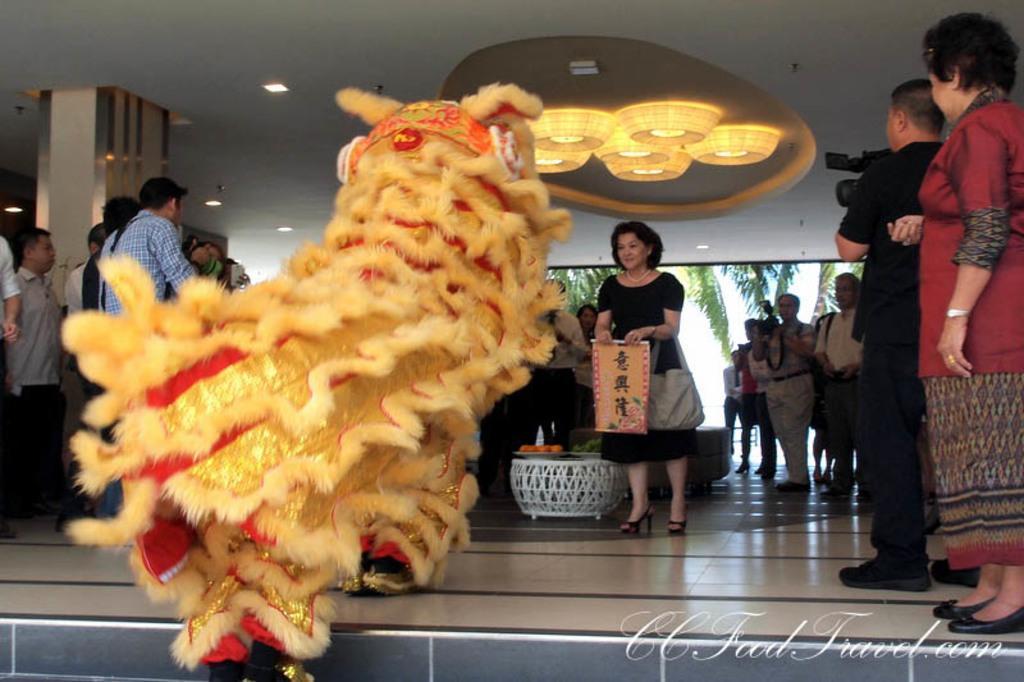Can you describe this image briefly? In this picture I can observe some people standing on the floor. There is a woman holding a cloth in her hand. There is some text on the cloth which is in different language. I can observe a person wearing a costume of an animal. In the background there are trees. 